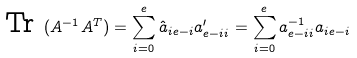Convert formula to latex. <formula><loc_0><loc_0><loc_500><loc_500>\text {Tr} \ ( A ^ { - 1 } A ^ { T } ) = \sum _ { i = 0 } ^ { e } \hat { a } _ { i e - i } a ^ { \prime } _ { e - i i } = \sum _ { i = 0 } ^ { e } a ^ { - 1 } _ { e - i i } a _ { i e - i }</formula> 